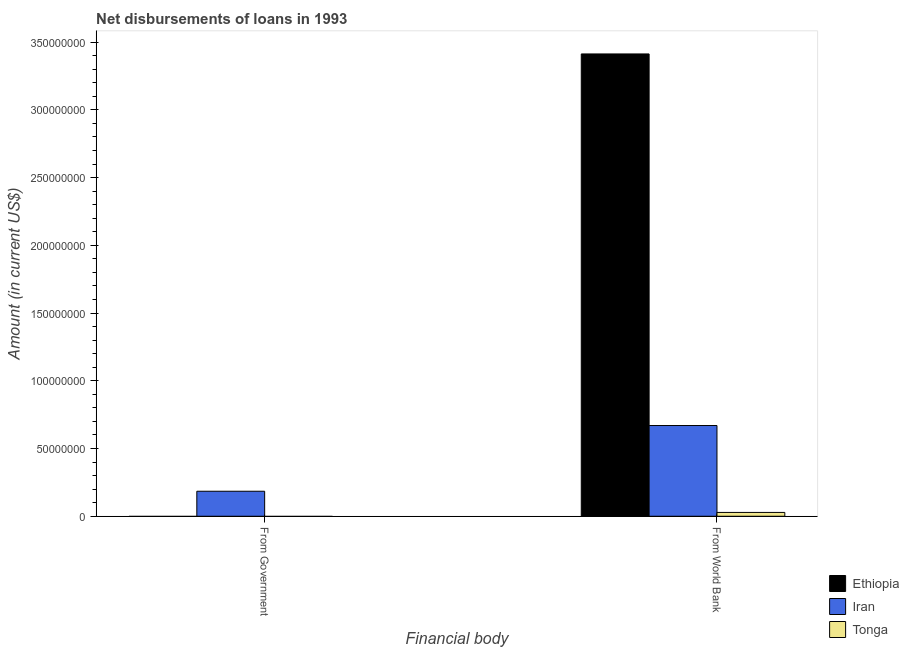How many different coloured bars are there?
Make the answer very short. 3. How many bars are there on the 2nd tick from the right?
Your answer should be very brief. 1. What is the label of the 2nd group of bars from the left?
Ensure brevity in your answer.  From World Bank. What is the net disbursements of loan from world bank in Ethiopia?
Your response must be concise. 3.41e+08. Across all countries, what is the maximum net disbursements of loan from world bank?
Ensure brevity in your answer.  3.41e+08. Across all countries, what is the minimum net disbursements of loan from government?
Offer a terse response. 0. In which country was the net disbursements of loan from world bank maximum?
Offer a terse response. Ethiopia. What is the total net disbursements of loan from world bank in the graph?
Ensure brevity in your answer.  4.11e+08. What is the difference between the net disbursements of loan from world bank in Iran and that in Tonga?
Offer a very short reply. 6.41e+07. What is the difference between the net disbursements of loan from government in Tonga and the net disbursements of loan from world bank in Iran?
Offer a terse response. -6.70e+07. What is the average net disbursements of loan from world bank per country?
Provide a short and direct response. 1.37e+08. What is the difference between the net disbursements of loan from world bank and net disbursements of loan from government in Iran?
Your answer should be very brief. 4.85e+07. What is the ratio of the net disbursements of loan from world bank in Tonga to that in Ethiopia?
Make the answer very short. 0.01. How many countries are there in the graph?
Your answer should be very brief. 3. What is the difference between two consecutive major ticks on the Y-axis?
Provide a succinct answer. 5.00e+07. What is the title of the graph?
Give a very brief answer. Net disbursements of loans in 1993. Does "Venezuela" appear as one of the legend labels in the graph?
Ensure brevity in your answer.  No. What is the label or title of the X-axis?
Offer a terse response. Financial body. What is the label or title of the Y-axis?
Make the answer very short. Amount (in current US$). What is the Amount (in current US$) in Ethiopia in From Government?
Provide a succinct answer. 0. What is the Amount (in current US$) of Iran in From Government?
Offer a terse response. 1.85e+07. What is the Amount (in current US$) of Tonga in From Government?
Ensure brevity in your answer.  0. What is the Amount (in current US$) of Ethiopia in From World Bank?
Your answer should be compact. 3.41e+08. What is the Amount (in current US$) of Iran in From World Bank?
Your answer should be very brief. 6.70e+07. What is the Amount (in current US$) of Tonga in From World Bank?
Your answer should be compact. 2.82e+06. Across all Financial body, what is the maximum Amount (in current US$) of Ethiopia?
Make the answer very short. 3.41e+08. Across all Financial body, what is the maximum Amount (in current US$) of Iran?
Offer a very short reply. 6.70e+07. Across all Financial body, what is the maximum Amount (in current US$) in Tonga?
Keep it short and to the point. 2.82e+06. Across all Financial body, what is the minimum Amount (in current US$) of Iran?
Provide a short and direct response. 1.85e+07. What is the total Amount (in current US$) of Ethiopia in the graph?
Provide a short and direct response. 3.41e+08. What is the total Amount (in current US$) in Iran in the graph?
Your response must be concise. 8.54e+07. What is the total Amount (in current US$) in Tonga in the graph?
Offer a very short reply. 2.82e+06. What is the difference between the Amount (in current US$) of Iran in From Government and that in From World Bank?
Make the answer very short. -4.85e+07. What is the difference between the Amount (in current US$) in Iran in From Government and the Amount (in current US$) in Tonga in From World Bank?
Your response must be concise. 1.56e+07. What is the average Amount (in current US$) in Ethiopia per Financial body?
Your answer should be compact. 1.71e+08. What is the average Amount (in current US$) of Iran per Financial body?
Your response must be concise. 4.27e+07. What is the average Amount (in current US$) in Tonga per Financial body?
Make the answer very short. 1.41e+06. What is the difference between the Amount (in current US$) of Ethiopia and Amount (in current US$) of Iran in From World Bank?
Your answer should be very brief. 2.74e+08. What is the difference between the Amount (in current US$) of Ethiopia and Amount (in current US$) of Tonga in From World Bank?
Offer a terse response. 3.38e+08. What is the difference between the Amount (in current US$) in Iran and Amount (in current US$) in Tonga in From World Bank?
Provide a short and direct response. 6.41e+07. What is the ratio of the Amount (in current US$) of Iran in From Government to that in From World Bank?
Offer a very short reply. 0.28. What is the difference between the highest and the second highest Amount (in current US$) in Iran?
Keep it short and to the point. 4.85e+07. What is the difference between the highest and the lowest Amount (in current US$) of Ethiopia?
Provide a succinct answer. 3.41e+08. What is the difference between the highest and the lowest Amount (in current US$) in Iran?
Ensure brevity in your answer.  4.85e+07. What is the difference between the highest and the lowest Amount (in current US$) in Tonga?
Provide a short and direct response. 2.82e+06. 